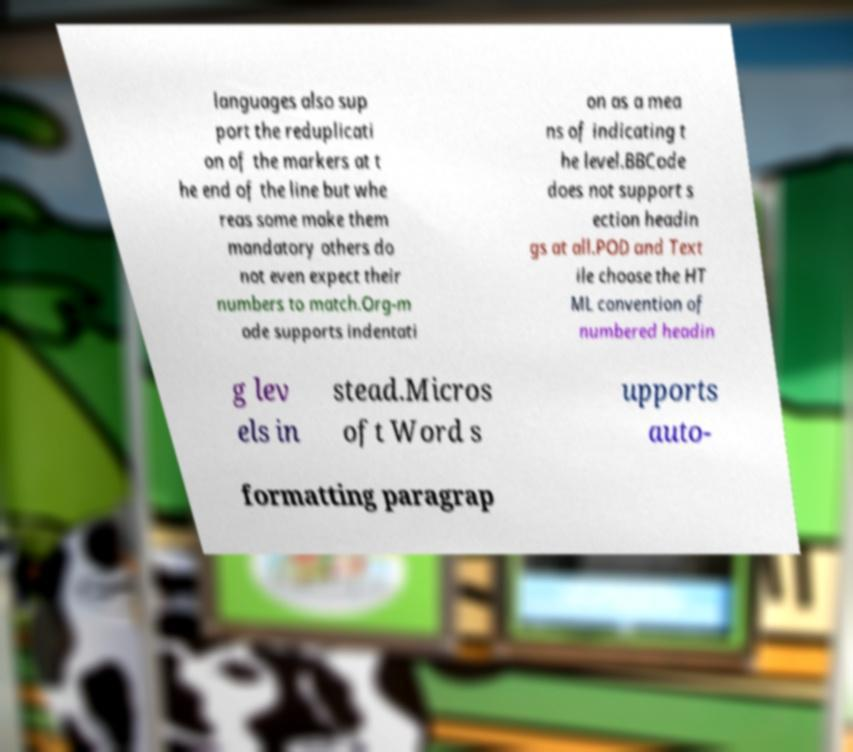Please identify and transcribe the text found in this image. languages also sup port the reduplicati on of the markers at t he end of the line but whe reas some make them mandatory others do not even expect their numbers to match.Org-m ode supports indentati on as a mea ns of indicating t he level.BBCode does not support s ection headin gs at all.POD and Text ile choose the HT ML convention of numbered headin g lev els in stead.Micros oft Word s upports auto- formatting paragrap 